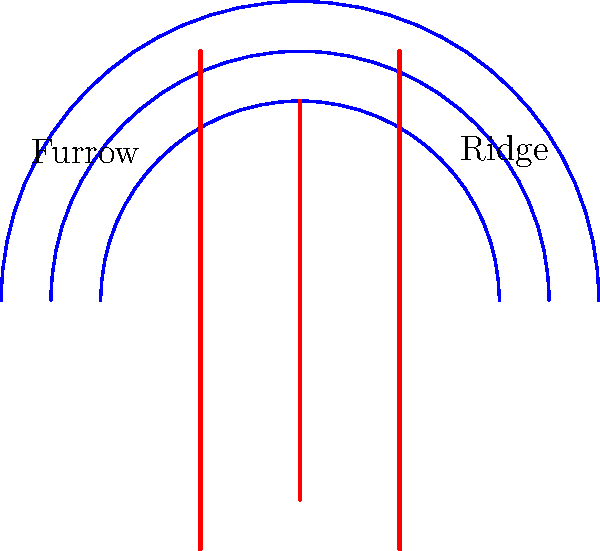In fingerprint analysis, which feature of the diagram is most crucial for distinguishing between individuals, and how might this knowledge be applied in maintaining a comprehensive law and crime section in a library? 1. The diagram illustrates the basic structure of a fingerprint, showing ridge patterns (red lines) and furrows (spaces between red lines).

2. Ridge patterns are unique to each individual, forming the basis of fingerprint identification.

3. The blue arcs represent the overall pattern types (e.g., loops, whorls, or arches) that categorize fingerprints broadly.

4. However, the most crucial feature for individual identification is the minutiae - specific points where ridges end, split, or join.

5. These minutiae points, though not explicitly shown in this simplified diagram, occur along the red ridge lines.

6. In maintaining a law and crime section, understanding this principle is vital for:
   a) Cataloging forensic science texts accurately
   b) Assisting researchers in understanding fingerprint evidence
   c) Organizing materials on biometric identification systems

7. Knowledge of ridge patterns and minutiae helps in properly categorizing and explaining the importance of fingerprint analysis in criminal investigations and legal proceedings.
Answer: Ridge patterns and their minutiae 